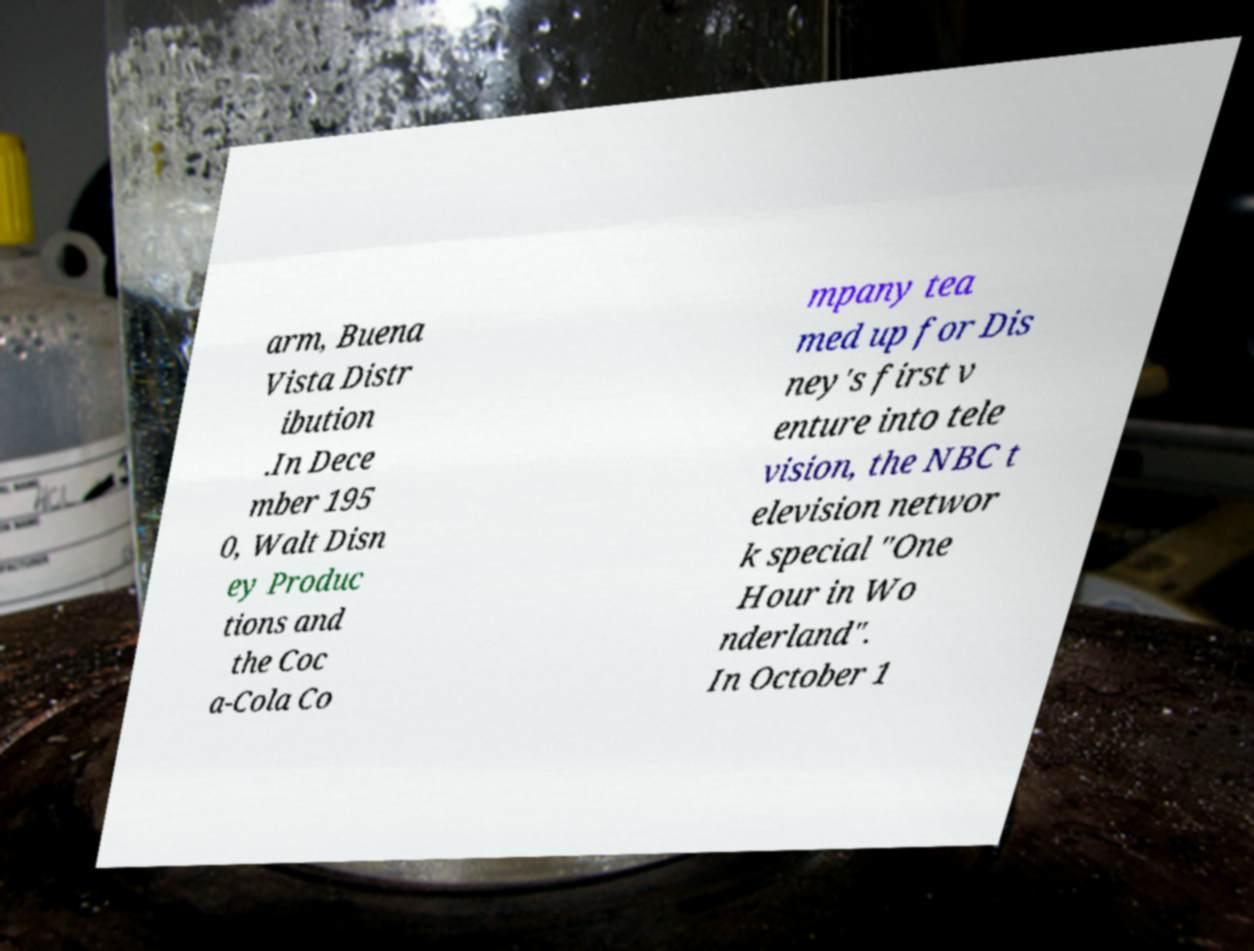Could you assist in decoding the text presented in this image and type it out clearly? arm, Buena Vista Distr ibution .In Dece mber 195 0, Walt Disn ey Produc tions and the Coc a-Cola Co mpany tea med up for Dis ney's first v enture into tele vision, the NBC t elevision networ k special "One Hour in Wo nderland". In October 1 